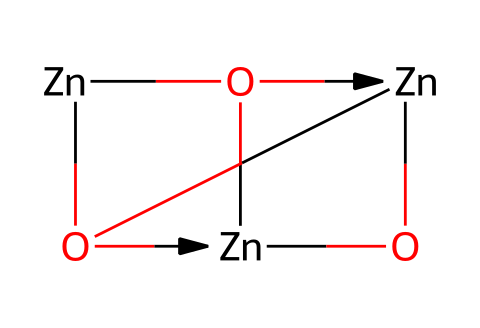What is the primary metal present in this chemical? The SMILES notation [Zn] indicates that zinc is the primary metal in the composition.
Answer: zinc How many oxygen atoms are in the structure? The SMILES string includes four instances of the letter 'O,' indicating there are four oxygen atoms.
Answer: four What type of quantum dots does this chemical represent? Since this structure is primarily composed of zinc and oxygen, it represents zinc oxide quantum dots, known for their UV protection properties.
Answer: zinc oxide How many zinc atoms are present in this chemical? The structure has three occurrences of the 'Zn' symbol, signifying that there are three zinc atoms in the molecular composition.
Answer: three What unique property do zinc oxide quantum dots provide in sunscreen formulations? Zinc oxide quantum dots are known for their ability to provide UV protection, thereby acting as effective sun blockers in sunscreen.
Answer: UV protection What is the bonding type present in this chemical structure? The presence of several atoms connected indicates that the structure involves covalent bonding, which is characteristic of compounds like zinc oxide.
Answer: covalent What does the arrangement of zinc and oxygen suggest about the potential applications of this chemical? The arrangement of zinc and oxygen suggests that it can be used in cosmetics and sunscreens for UV protection, due to properties associated with zinc oxide.
Answer: UV protection in cosmetics 